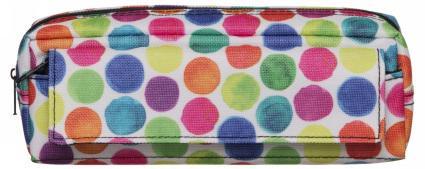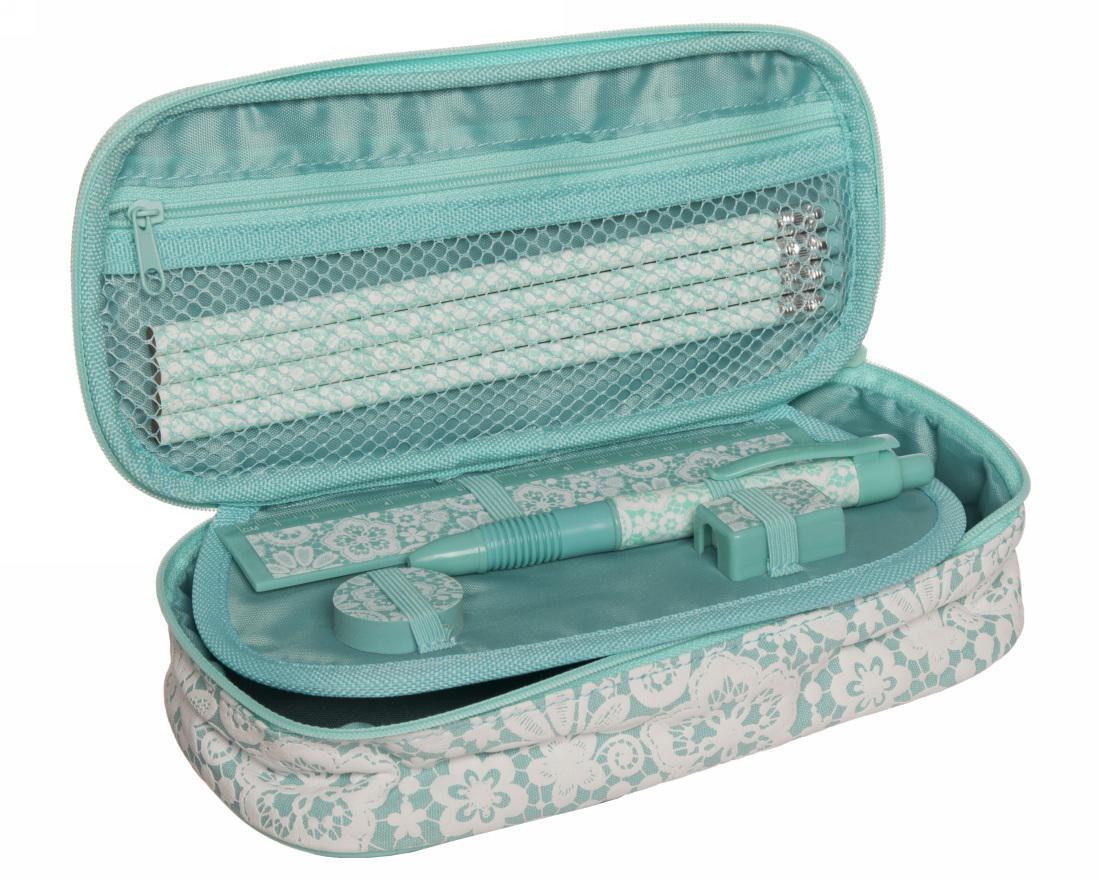The first image is the image on the left, the second image is the image on the right. Assess this claim about the two images: "No case is displayed open, and at least one rectangular case with rounded corners and hot pink color scheme is displayed standing on its long side.". Correct or not? Answer yes or no. No. 